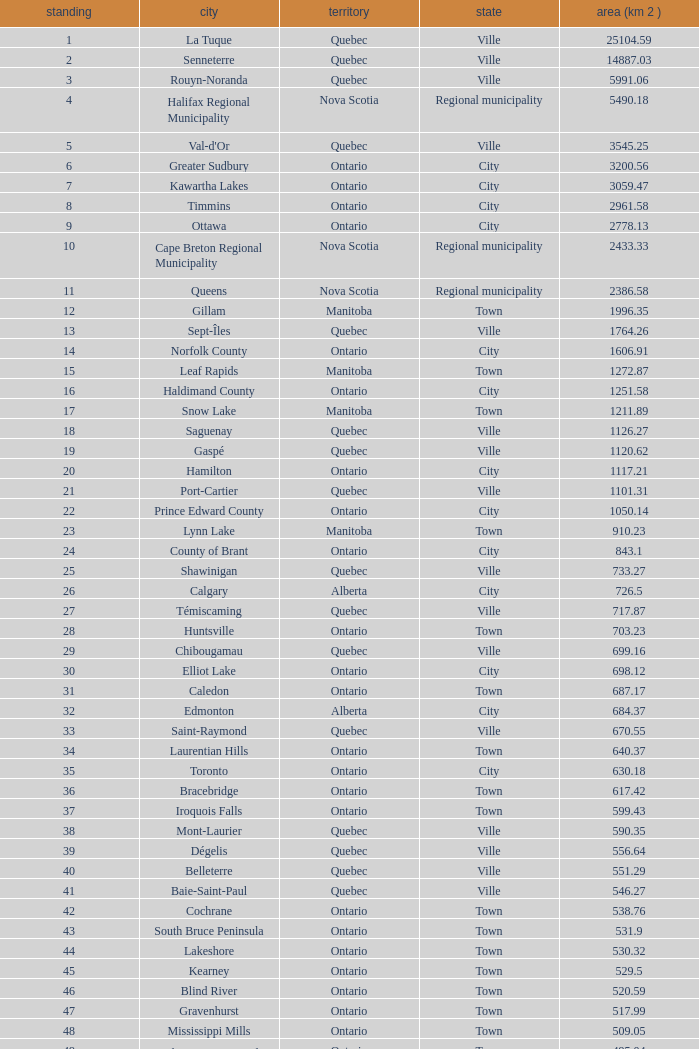What is the total Rank that has a Municipality of Winnipeg, an Area (KM 2) that's larger than 464.01? None. 